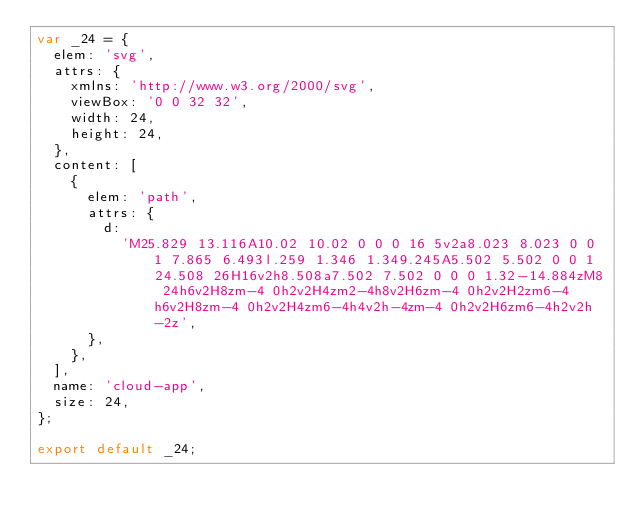<code> <loc_0><loc_0><loc_500><loc_500><_JavaScript_>var _24 = {
  elem: 'svg',
  attrs: {
    xmlns: 'http://www.w3.org/2000/svg',
    viewBox: '0 0 32 32',
    width: 24,
    height: 24,
  },
  content: [
    {
      elem: 'path',
      attrs: {
        d:
          'M25.829 13.116A10.02 10.02 0 0 0 16 5v2a8.023 8.023 0 0 1 7.865 6.493l.259 1.346 1.349.245A5.502 5.502 0 0 1 24.508 26H16v2h8.508a7.502 7.502 0 0 0 1.32-14.884zM8 24h6v2H8zm-4 0h2v2H4zm2-4h8v2H6zm-4 0h2v2H2zm6-4h6v2H8zm-4 0h2v2H4zm6-4h4v2h-4zm-4 0h2v2H6zm6-4h2v2h-2z',
      },
    },
  ],
  name: 'cloud-app',
  size: 24,
};

export default _24;
</code> 